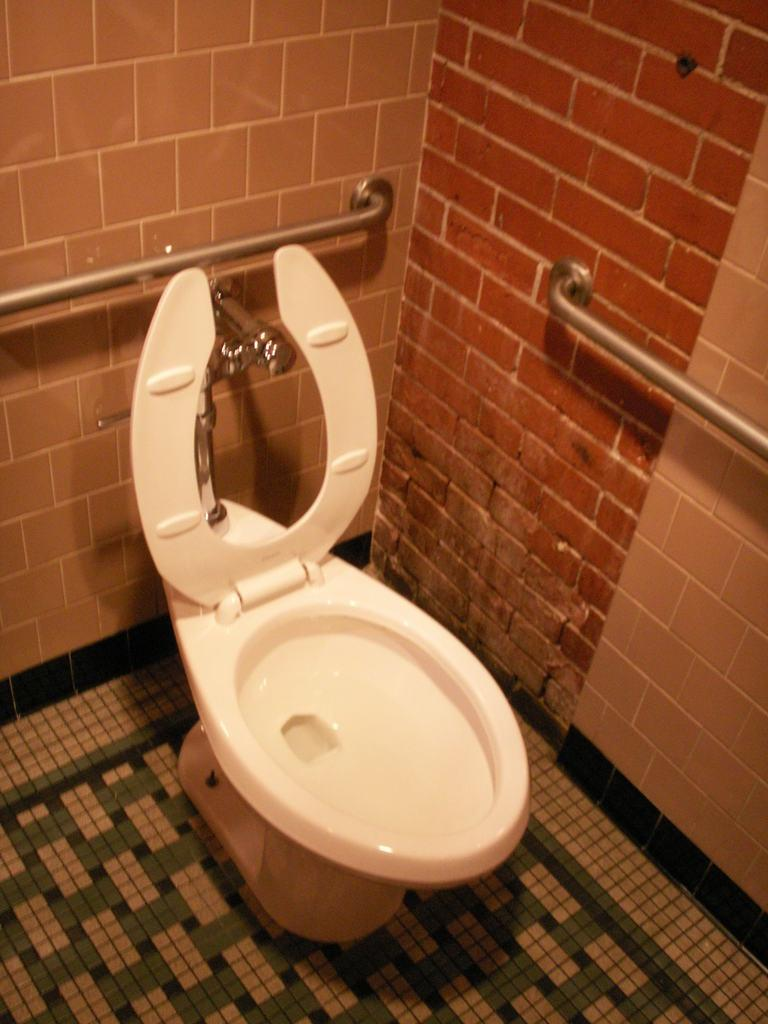What object is placed on the floor in the image? There is a toilet seat on the floor in the image. What can be seen attached to the wall in the image? There are metal rods and a tap attached to the wall in the image. What type of potato is being grown in the town depicted in the image? There is no town or potato present in the image; it only features a toilet seat on the floor and metal rods and a tap attached to the wall. 